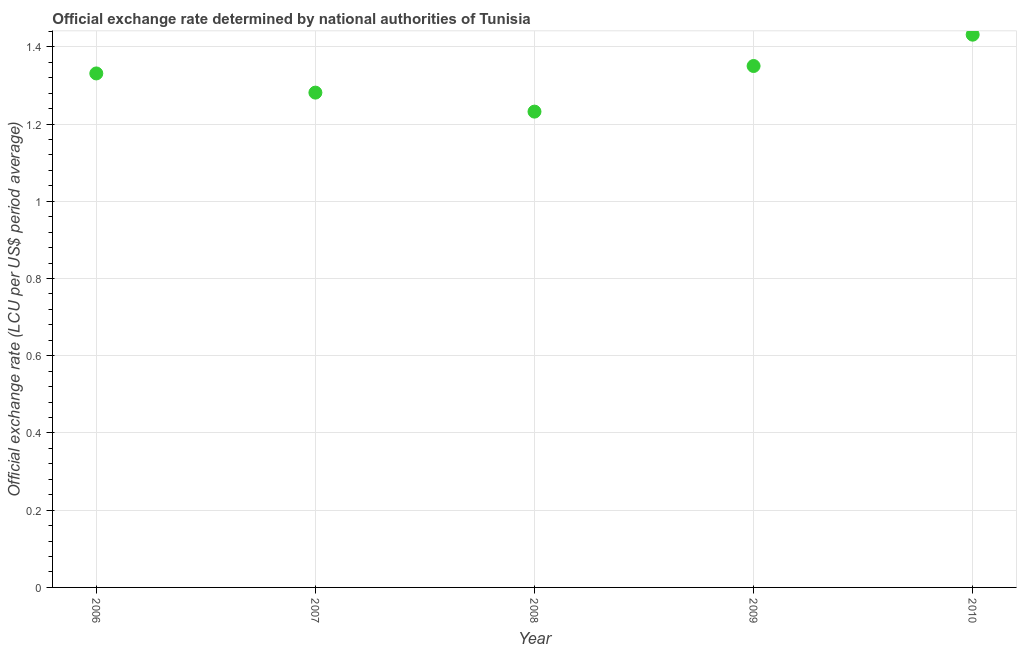What is the official exchange rate in 2007?
Your answer should be very brief. 1.28. Across all years, what is the maximum official exchange rate?
Give a very brief answer. 1.43. Across all years, what is the minimum official exchange rate?
Give a very brief answer. 1.23. What is the sum of the official exchange rate?
Your answer should be compact. 6.63. What is the difference between the official exchange rate in 2006 and 2010?
Provide a succinct answer. -0.1. What is the average official exchange rate per year?
Offer a terse response. 1.33. What is the median official exchange rate?
Make the answer very short. 1.33. What is the ratio of the official exchange rate in 2008 to that in 2009?
Keep it short and to the point. 0.91. What is the difference between the highest and the second highest official exchange rate?
Provide a succinct answer. 0.08. Is the sum of the official exchange rate in 2006 and 2010 greater than the maximum official exchange rate across all years?
Make the answer very short. Yes. What is the difference between the highest and the lowest official exchange rate?
Offer a very short reply. 0.2. In how many years, is the official exchange rate greater than the average official exchange rate taken over all years?
Ensure brevity in your answer.  3. Does the official exchange rate monotonically increase over the years?
Your response must be concise. No. How many dotlines are there?
Offer a very short reply. 1. What is the title of the graph?
Offer a terse response. Official exchange rate determined by national authorities of Tunisia. What is the label or title of the Y-axis?
Offer a very short reply. Official exchange rate (LCU per US$ period average). What is the Official exchange rate (LCU per US$ period average) in 2006?
Your answer should be very brief. 1.33. What is the Official exchange rate (LCU per US$ period average) in 2007?
Ensure brevity in your answer.  1.28. What is the Official exchange rate (LCU per US$ period average) in 2008?
Your answer should be very brief. 1.23. What is the Official exchange rate (LCU per US$ period average) in 2009?
Offer a terse response. 1.35. What is the Official exchange rate (LCU per US$ period average) in 2010?
Provide a succinct answer. 1.43. What is the difference between the Official exchange rate (LCU per US$ period average) in 2006 and 2007?
Make the answer very short. 0.05. What is the difference between the Official exchange rate (LCU per US$ period average) in 2006 and 2008?
Your answer should be compact. 0.1. What is the difference between the Official exchange rate (LCU per US$ period average) in 2006 and 2009?
Make the answer very short. -0.02. What is the difference between the Official exchange rate (LCU per US$ period average) in 2006 and 2010?
Provide a succinct answer. -0.1. What is the difference between the Official exchange rate (LCU per US$ period average) in 2007 and 2008?
Keep it short and to the point. 0.05. What is the difference between the Official exchange rate (LCU per US$ period average) in 2007 and 2009?
Ensure brevity in your answer.  -0.07. What is the difference between the Official exchange rate (LCU per US$ period average) in 2007 and 2010?
Keep it short and to the point. -0.15. What is the difference between the Official exchange rate (LCU per US$ period average) in 2008 and 2009?
Make the answer very short. -0.12. What is the difference between the Official exchange rate (LCU per US$ period average) in 2008 and 2010?
Provide a succinct answer. -0.2. What is the difference between the Official exchange rate (LCU per US$ period average) in 2009 and 2010?
Your response must be concise. -0.08. What is the ratio of the Official exchange rate (LCU per US$ period average) in 2006 to that in 2007?
Your answer should be compact. 1.04. What is the ratio of the Official exchange rate (LCU per US$ period average) in 2006 to that in 2008?
Your response must be concise. 1.08. What is the ratio of the Official exchange rate (LCU per US$ period average) in 2006 to that in 2009?
Your response must be concise. 0.99. What is the ratio of the Official exchange rate (LCU per US$ period average) in 2007 to that in 2009?
Offer a very short reply. 0.95. What is the ratio of the Official exchange rate (LCU per US$ period average) in 2007 to that in 2010?
Provide a short and direct response. 0.9. What is the ratio of the Official exchange rate (LCU per US$ period average) in 2008 to that in 2010?
Make the answer very short. 0.86. What is the ratio of the Official exchange rate (LCU per US$ period average) in 2009 to that in 2010?
Your answer should be very brief. 0.94. 